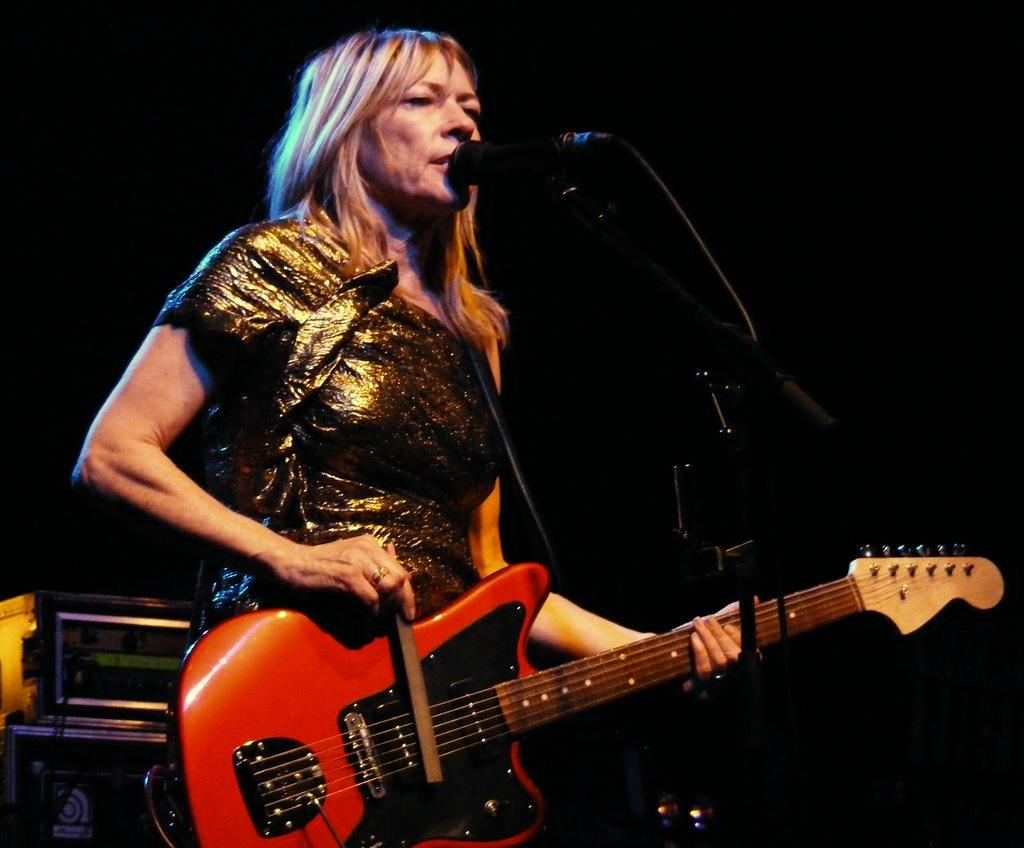Who is the main subject in the image? There is a woman in the image. What is the woman doing in the image? The woman is standing in front of a microphone. What is the woman wearing in the image? The woman is wearing a colorful dress. What object is the woman holding in the image? The woman is holding a guitar in her hand. What type of shop can be seen in the background of the image? There is no shop visible in the image; it only features the woman, the microphone, and the guitar. Is the woman folding any clothes in the image? No, the woman is not folding any clothes in the image; she is holding a guitar and standing in front of a microphone. 